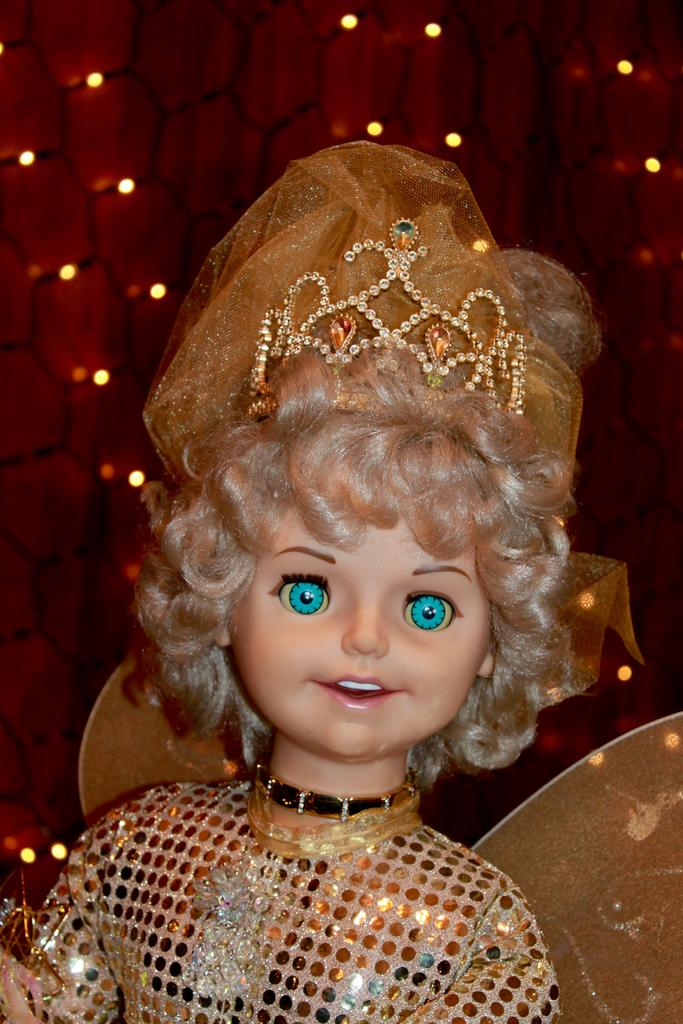What type of toy is present in the image? There is a toy girl in the image. What is the toy girl wearing? The toy girl is wearing a golden dress and a crown. What can be seen in the background of the image? There are lights in the background of the image. What type of answer does the toy girl give in the image? There is no indication in the image that the toy girl is giving an answer, as she is a toy and not a person. 